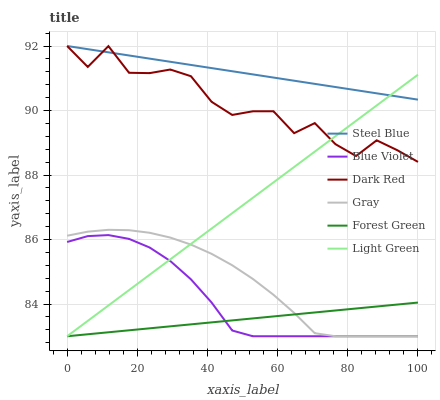Does Forest Green have the minimum area under the curve?
Answer yes or no. Yes. Does Steel Blue have the maximum area under the curve?
Answer yes or no. Yes. Does Dark Red have the minimum area under the curve?
Answer yes or no. No. Does Dark Red have the maximum area under the curve?
Answer yes or no. No. Is Steel Blue the smoothest?
Answer yes or no. Yes. Is Dark Red the roughest?
Answer yes or no. Yes. Is Dark Red the smoothest?
Answer yes or no. No. Is Steel Blue the roughest?
Answer yes or no. No. Does Dark Red have the lowest value?
Answer yes or no. No. Does Forest Green have the highest value?
Answer yes or no. No. Is Gray less than Steel Blue?
Answer yes or no. Yes. Is Dark Red greater than Forest Green?
Answer yes or no. Yes. Does Gray intersect Steel Blue?
Answer yes or no. No. 